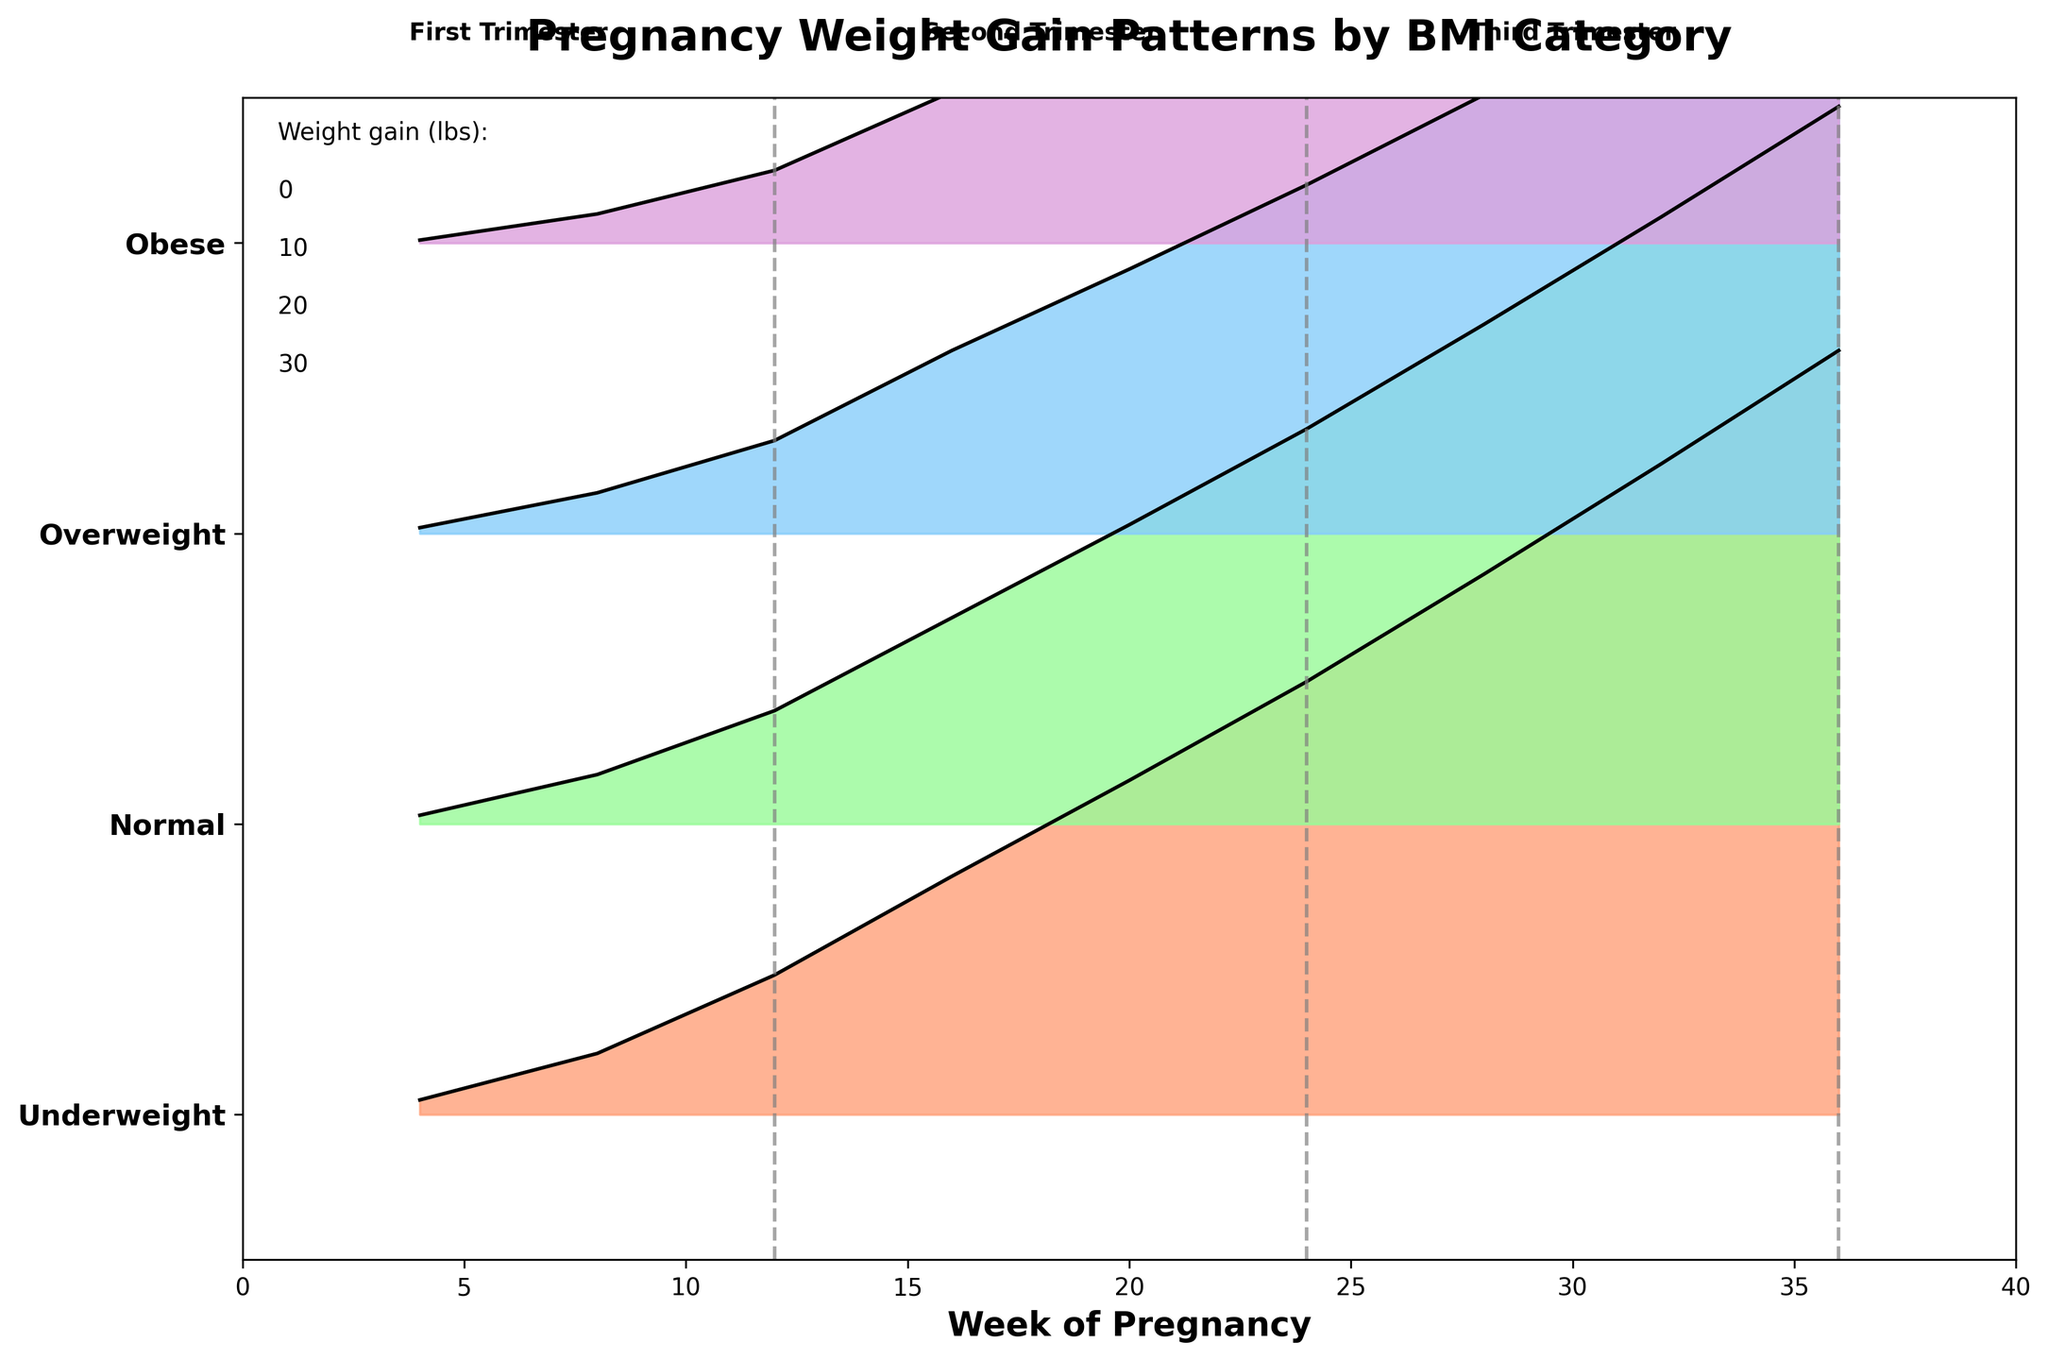What is the title of the plot? The title of the plot is usually displayed at the top and is a concise summary of what the plot is about. The title of this plot says "Pregnancy Weight Gain Patterns by BMI Category".
Answer: Pregnancy Weight Gain Patterns by BMI Category How many BMI categories are represented in the plot? The y-axis shows different BMI categories. By counting the labels on the y-axis, you can see there are four BMI categories: Underweight, Normal, Overweight, and Obese.
Answer: 4 During which weeks are the trimesters divided by the vertical dashed lines? The vertical dashed lines divide the trimesters. The first of these lines is at Week 12, the second is at Week 24, and the third is at Week 36.
Answer: 12, 24, and 36 Which BMI category experienced the highest weight gain by Week 36? By examining the topmost lines for Week 36 in the ridgeline plot, the "Underweight" category is the highest, indicating it experienced the highest weight gain at that week.
Answer: Underweight Is the weight gain trend generally increasing or decreasing over the weeks? Looking at the lines from the left to the right side of the plot, all lines are trending upwards, indicating an overall increase in weight gain across all BMI categories as the weeks progress.
Answer: Increasing Which BMI category had the smallest weight gain by the end of the first trimester (Week 12)? In Week 12, the bottommost line represents the category with the smallest weight gain. Since "Obese" is at the bottom, it had the smallest weight gain by the end of the first trimester.
Answer: Obese What is the approximate weight gain for normal BMI at Week 24? At Week 24, find the plot line for the "Normal" BMI category. The y-value around Week 24 for the "Normal" BMI is approximately 13.6 according to the data.
Answer: 13.6 lbs Compare the weight gain between "Overweight" and "Obese" categories in the second trimester. Which category gained more weight on average? For the second trimester (Weeks 16-24), the average weight gain for "Overweight" is higher compared to "Obese" when you look at the vertical placement of the lines on the plot at Weeks 16, 20, and 24.
Answer: Overweight In which trimester does the weight gain pattern appear the steepest for the Underweight category? The steepness of the line can be observed by the angle of the incline. The steepest incline for Underweight is seen in the third trimester (Weeks 24-36) where the increase in weight gain is the most rapid.
Answer: Third trimester 